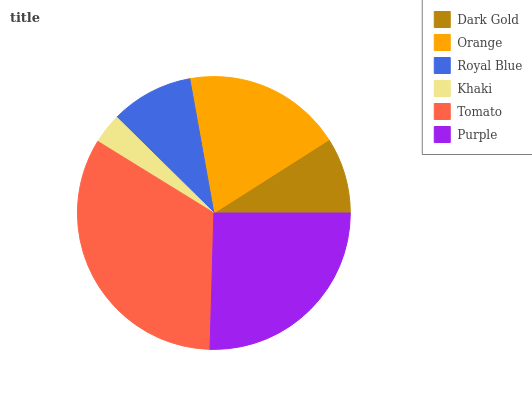Is Khaki the minimum?
Answer yes or no. Yes. Is Tomato the maximum?
Answer yes or no. Yes. Is Orange the minimum?
Answer yes or no. No. Is Orange the maximum?
Answer yes or no. No. Is Orange greater than Dark Gold?
Answer yes or no. Yes. Is Dark Gold less than Orange?
Answer yes or no. Yes. Is Dark Gold greater than Orange?
Answer yes or no. No. Is Orange less than Dark Gold?
Answer yes or no. No. Is Orange the high median?
Answer yes or no. Yes. Is Royal Blue the low median?
Answer yes or no. Yes. Is Tomato the high median?
Answer yes or no. No. Is Dark Gold the low median?
Answer yes or no. No. 